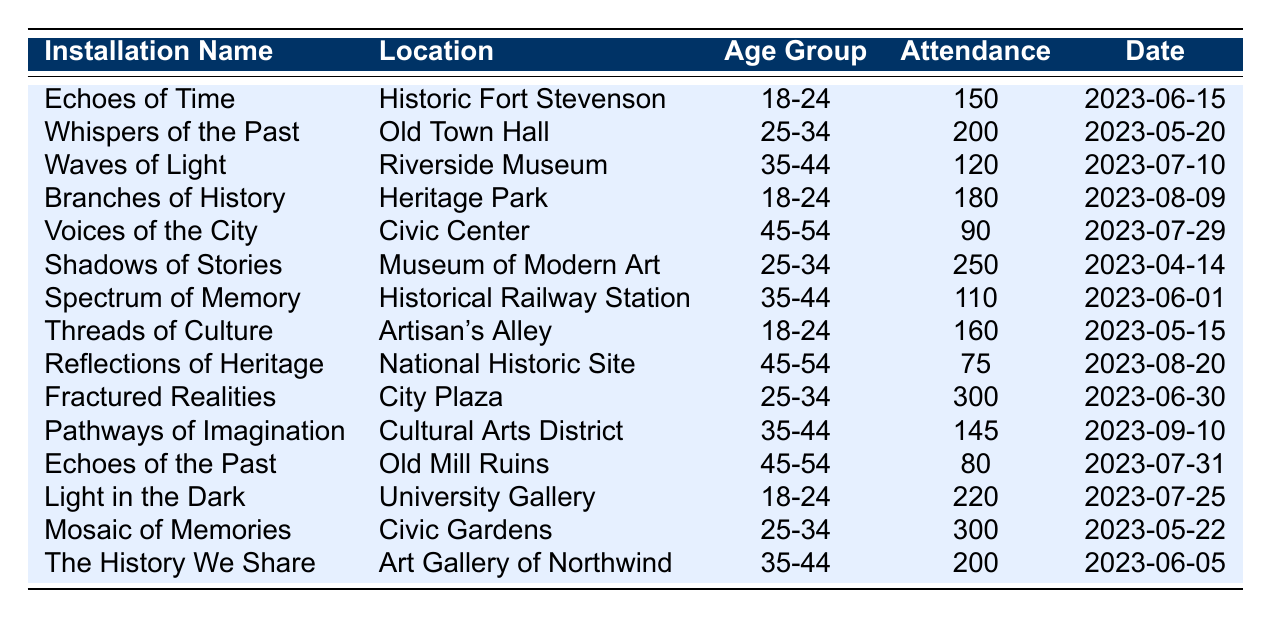What is the attendance for the installation "Shadows of Stories"? The table lists the installation "Shadows of Stories" with an attendance of 250.
Answer: 250 Which age group had the highest attendance for the installations? The highest attendance is 300 for the age group 25-34 from two installations: "Fractured Realities" and "Mosaic of Memories".
Answer: 25-34 What installation had the lowest attendance and what was the age group? The installation with the lowest attendance is "Reflections of Heritage," with 75 attendees from the age group 45-54.
Answer: Reflections of Heritage, 45-54 How many installations were held in the age group 18-24? The data shows three installations for the age group 18-24: "Echoes of Time," "Branches of History," and "Threads of Culture."
Answer: 3 What is the total attendance for all 25-34 age group installations? The total attendance for the age group 25-34 can be calculated as follows: 200 (Whispers of the Past) + 250 (Shadows of Stories) + 300 (Fractured Realities) + 300 (Mosaic of Memories) = 1050.
Answer: 1050 Is there an installation that has exactly 200 attendees? Yes, the installations "The History We Share" (35-44) and "Fractured Realities" (25-34) both had 200 attendees.
Answer: Yes What is the average attendance for the age group 35-44? The attendance for the age group 35-44 is summarized as follows: 120 (Waves of Light) + 110 (Spectrum of Memory) + 145 (Pathways of Imagination) + 200 (The History We Share) = 575. There are four installations, so the average is 575/4 = 143.75.
Answer: 143.75 Which installation had the highest attendance overall? The installation with the highest overall attendance is "Fractured Realities" with 300 attendees.
Answer: Fractured Realities How does the attendance of the installation "Echoes of Time" compare to "Light in the Dark"? "Echoes of Time" had an attendance of 150, while "Light in the Dark" had an attendance of 220. Therefore, "Light in the Dark" had 70 more attendees than "Echoes of Time."
Answer: 70 more How many total attendees were there from the age group 45-54? The total number of attendees for the age group 45-54 can be calculated as follows: 90 (Voices of the City) + 75 (Reflections of Heritage) + 80 (Echoes of the Past) = 245.
Answer: 245 